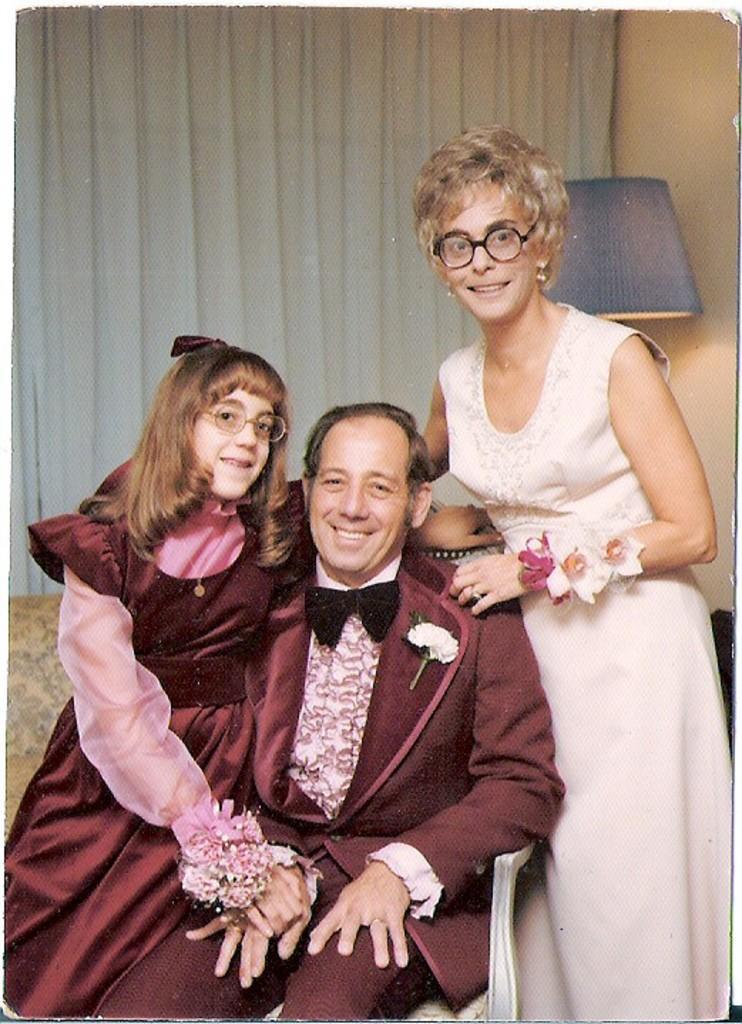How would you summarize this image in a sentence or two? In this picture we can see three persons here, in the background there is a curtain, we can see a lamp here, on the right side there is a wall. 